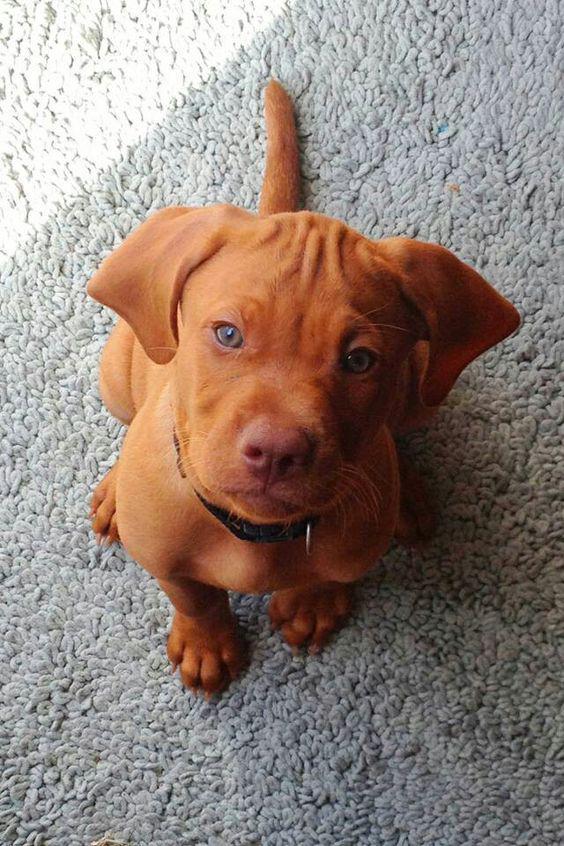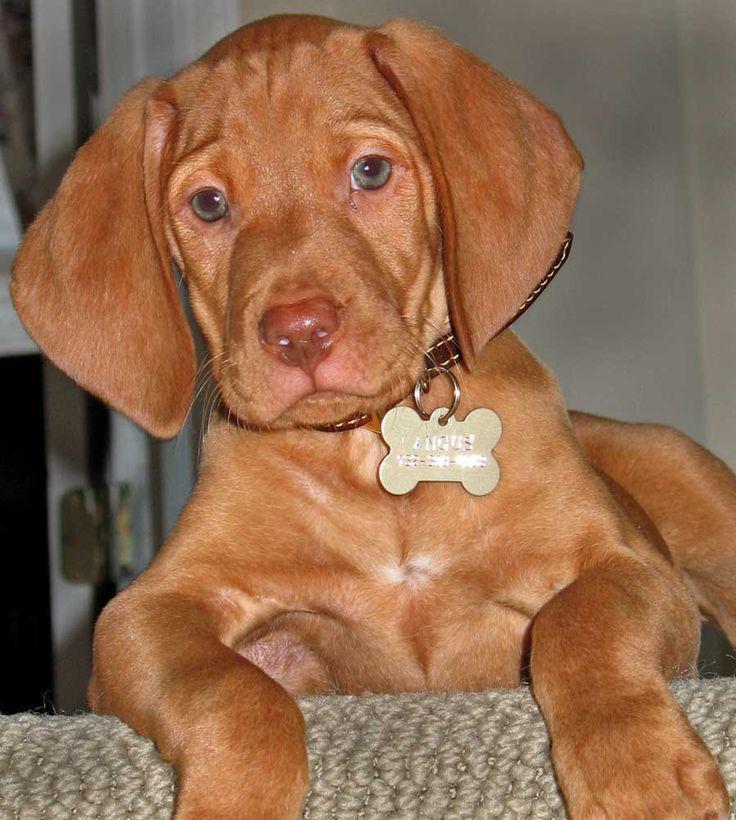The first image is the image on the left, the second image is the image on the right. Evaluate the accuracy of this statement regarding the images: "A dog is sitting on a tile floor.". Is it true? Answer yes or no. No. The first image is the image on the left, the second image is the image on the right. Examine the images to the left and right. Is the description "One image shows a red-orange puppy wearing a collar in an upright sitting pose, and the other image shows a puppy with at least one front paw propped on something off the ground." accurate? Answer yes or no. Yes. 